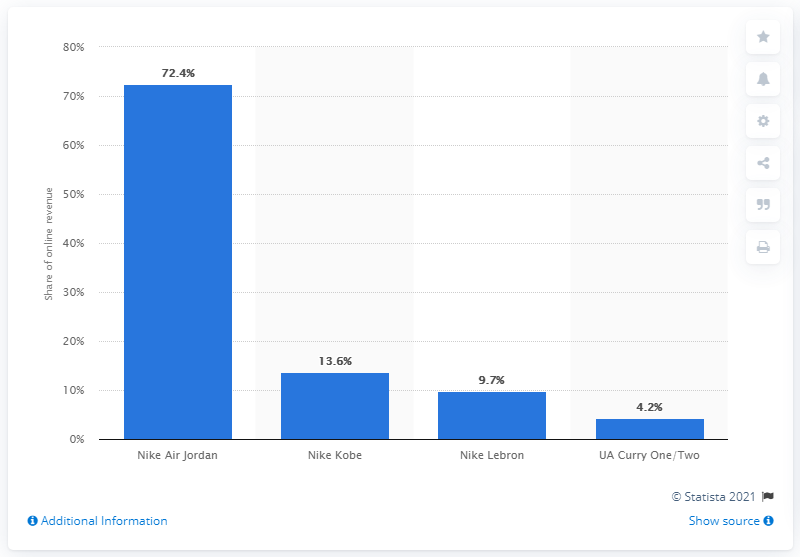Mention a couple of crucial points in this snapshot. Nike's Kobe Bryant shoe placed second in online sales, exhibiting its popularity among consumers. 